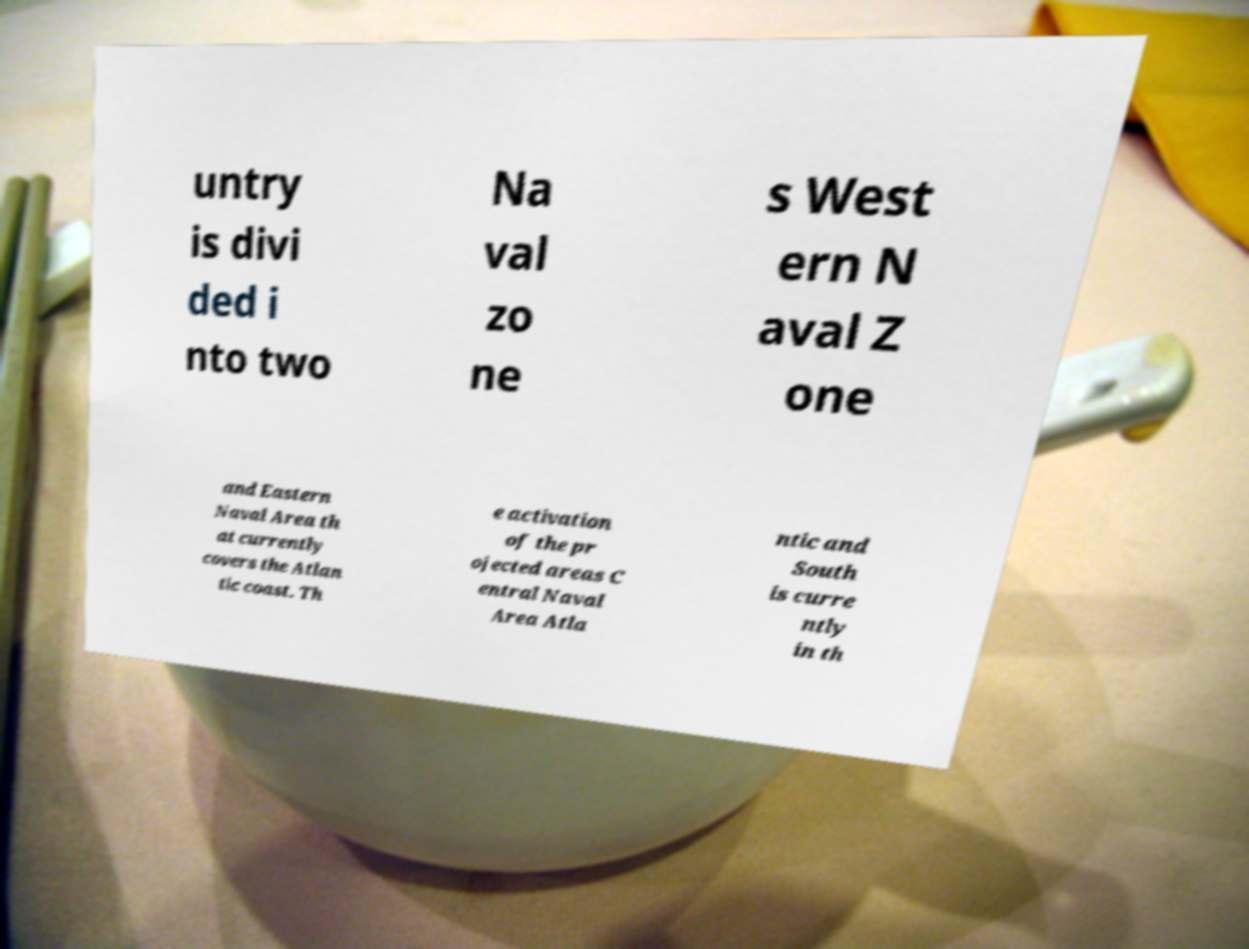There's text embedded in this image that I need extracted. Can you transcribe it verbatim? untry is divi ded i nto two Na val zo ne s West ern N aval Z one and Eastern Naval Area th at currently covers the Atlan tic coast. Th e activation of the pr ojected areas C entral Naval Area Atla ntic and South is curre ntly in th 